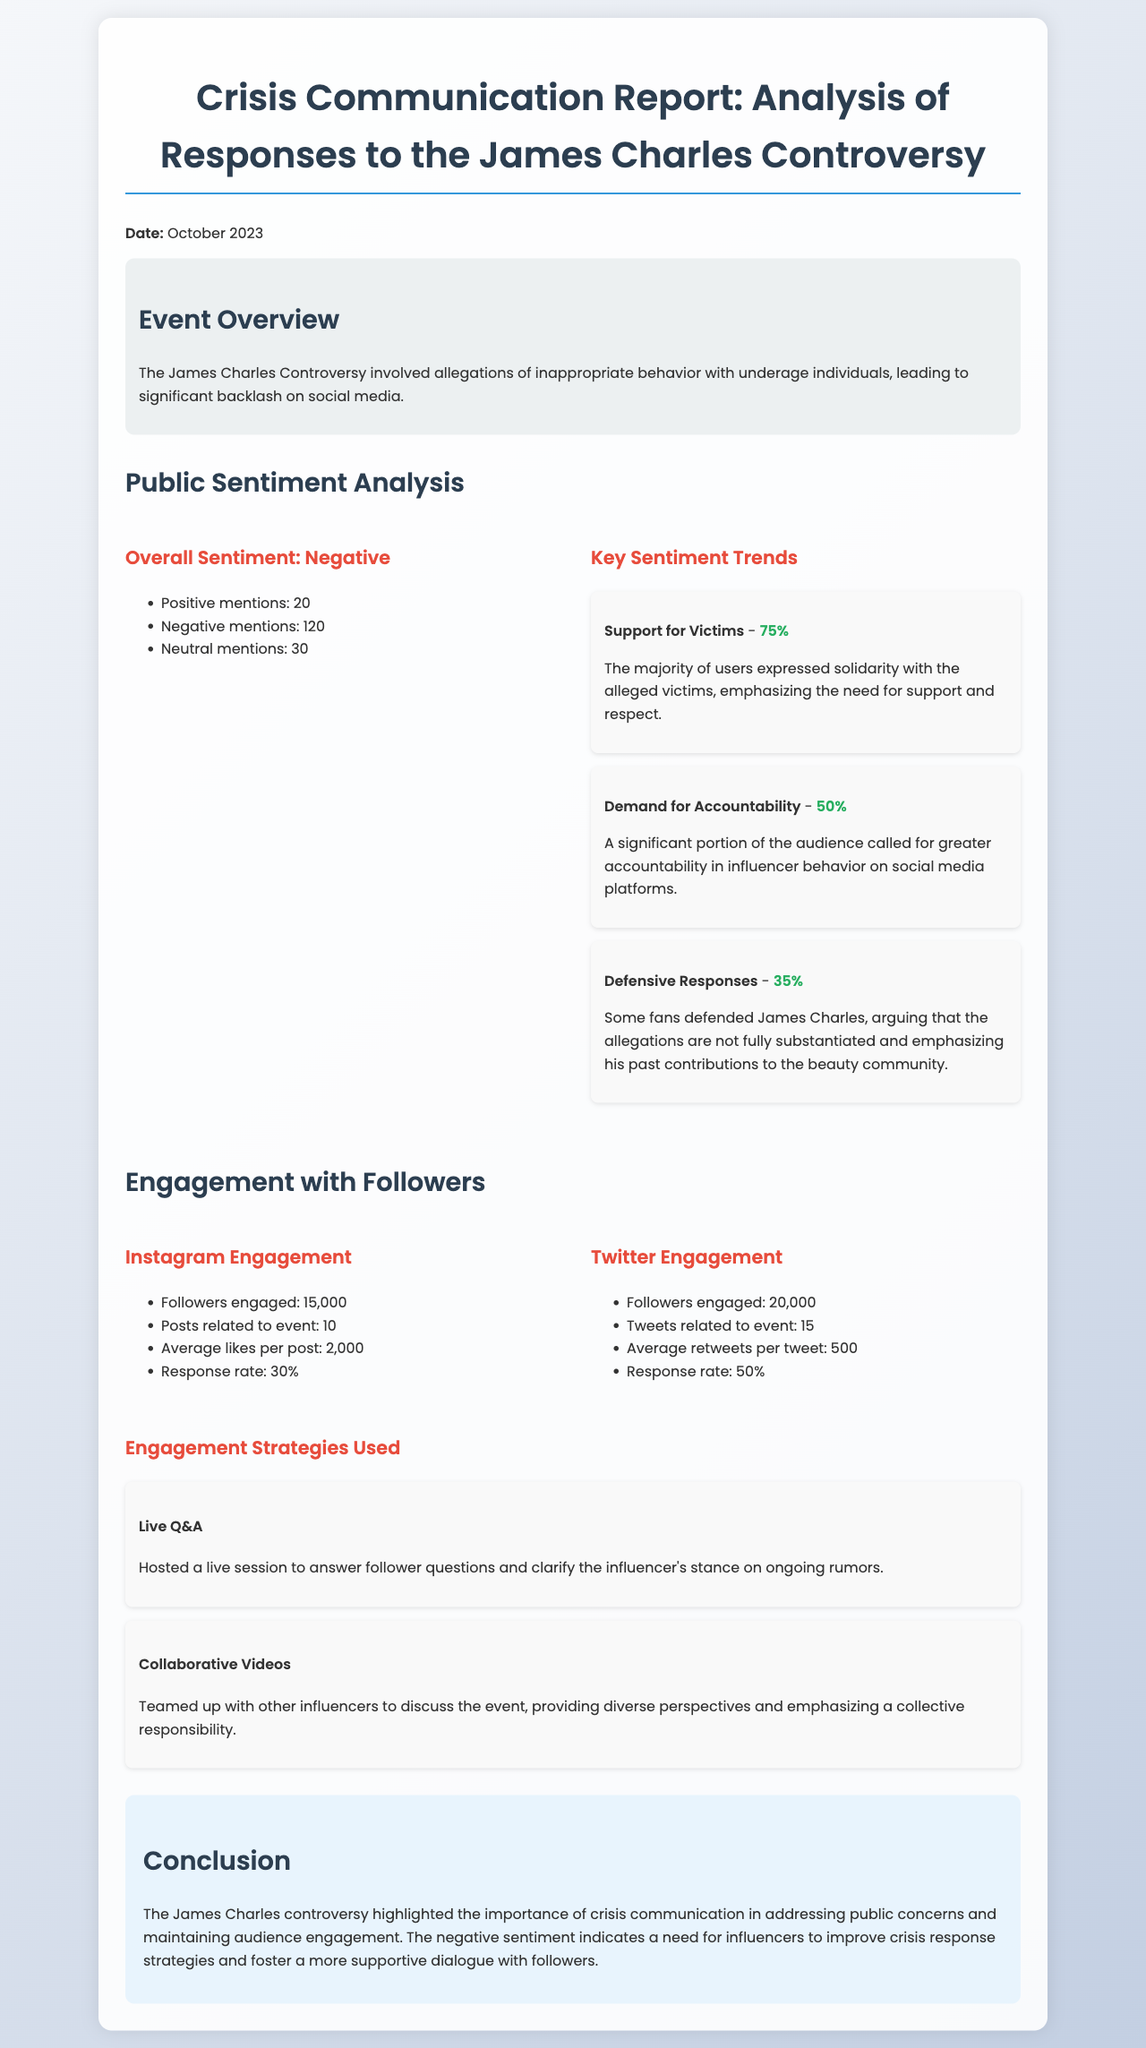what is the date of the report? The report is dated October 2023, as mentioned at the beginning of the document.
Answer: October 2023 how many positive mentions were there in the sentiment analysis? The document states there were 20 positive mentions in the sentiment analysis section.
Answer: 20 what percentage of users expressed support for victims? The report details that 75% of users expressed support for victims according to the sentiment trends.
Answer: 75% how many followers engaged on Twitter? The engagement analysis section specifies that 20,000 followers were engaged on Twitter.
Answer: 20,000 what was the average likes per post on Instagram? The document mentions that the average likes per Instagram post were 2,000 during this controversy.
Answer: 2,000 which engagement strategy involved a live session? The report lists "Live Q&A" as one of the engagement strategies used to clarify the influencer's stance.
Answer: Live Q&A what is the overall sentiment reported in the analysis? The sentiment analysis section states the overall sentiment observed was negative.
Answer: Negative how many posts related to the event were made on Instagram? According to the document, there were 10 posts related to the event on Instagram.
Answer: 10 what was the response rate on Twitter? The engagement analysis shows a 50% response rate on Twitter during the controversy.
Answer: 50% 